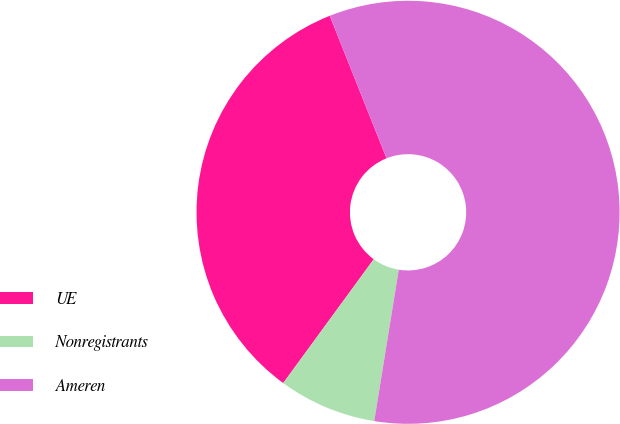<chart> <loc_0><loc_0><loc_500><loc_500><pie_chart><fcel>UE<fcel>Nonregistrants<fcel>Ameren<nl><fcel>33.92%<fcel>7.49%<fcel>58.59%<nl></chart> 